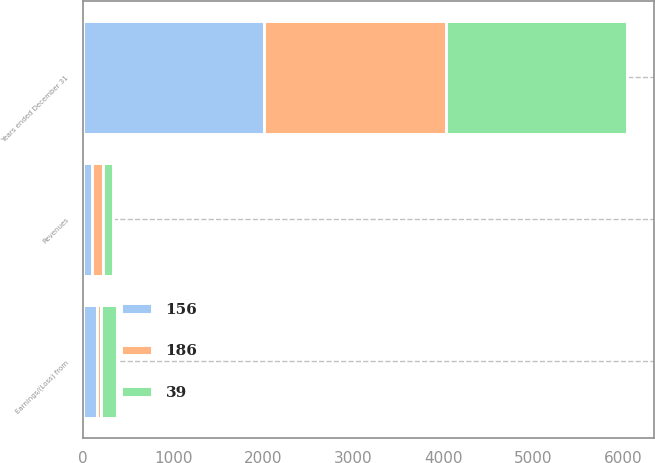<chart> <loc_0><loc_0><loc_500><loc_500><stacked_bar_chart><ecel><fcel>Years ended December 31<fcel>Revenues<fcel>Earnings/(Loss) from<nl><fcel>156<fcel>2013<fcel>102<fcel>156<nl><fcel>39<fcel>2012<fcel>106<fcel>186<nl><fcel>186<fcel>2011<fcel>123<fcel>39<nl></chart> 